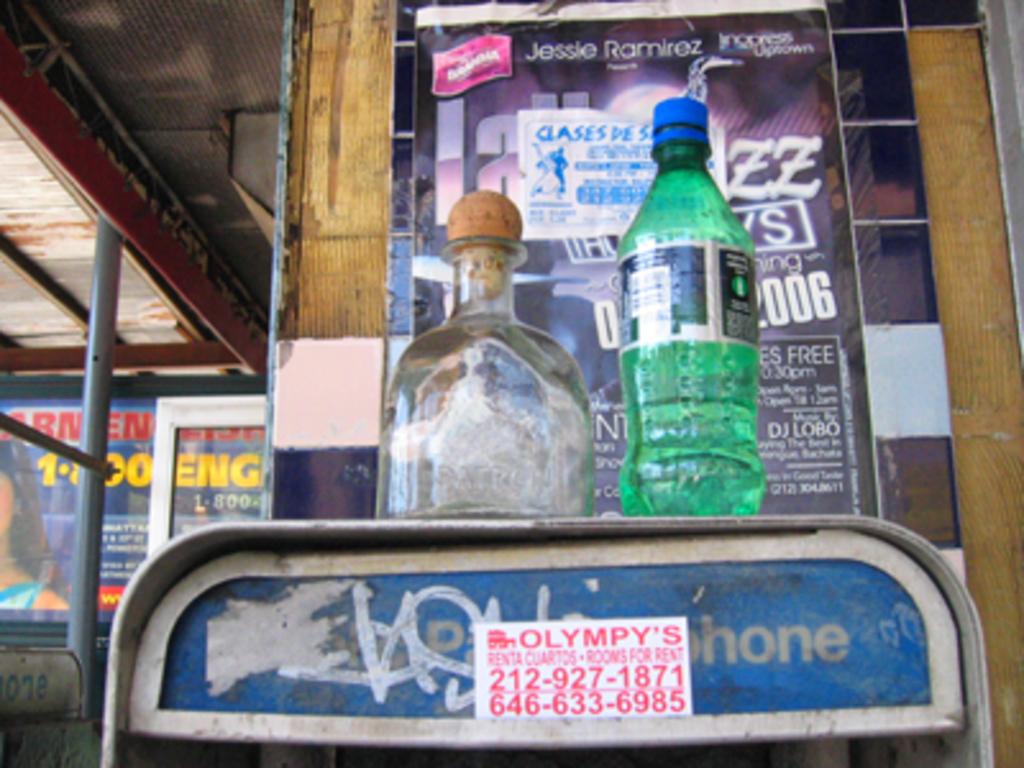What is the business name listed on the telephone booth sticker?
Provide a succinct answer. Olympy's. What is the stickers phone number?
Offer a terse response. 2129271871. 